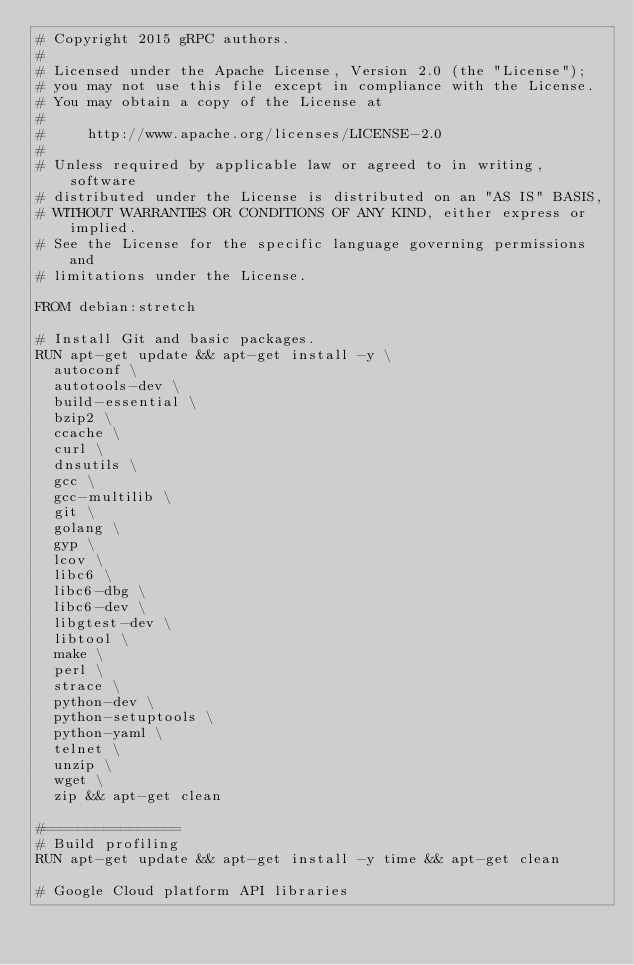<code> <loc_0><loc_0><loc_500><loc_500><_Dockerfile_># Copyright 2015 gRPC authors.
#
# Licensed under the Apache License, Version 2.0 (the "License");
# you may not use this file except in compliance with the License.
# You may obtain a copy of the License at
#
#     http://www.apache.org/licenses/LICENSE-2.0
#
# Unless required by applicable law or agreed to in writing, software
# distributed under the License is distributed on an "AS IS" BASIS,
# WITHOUT WARRANTIES OR CONDITIONS OF ANY KIND, either express or implied.
# See the License for the specific language governing permissions and
# limitations under the License.

FROM debian:stretch
  
# Install Git and basic packages.
RUN apt-get update && apt-get install -y \
  autoconf \
  autotools-dev \
  build-essential \
  bzip2 \
  ccache \
  curl \
  dnsutils \
  gcc \
  gcc-multilib \
  git \
  golang \
  gyp \
  lcov \
  libc6 \
  libc6-dbg \
  libc6-dev \
  libgtest-dev \
  libtool \
  make \
  perl \
  strace \
  python-dev \
  python-setuptools \
  python-yaml \
  telnet \
  unzip \
  wget \
  zip && apt-get clean

#================
# Build profiling
RUN apt-get update && apt-get install -y time && apt-get clean

# Google Cloud platform API libraries</code> 